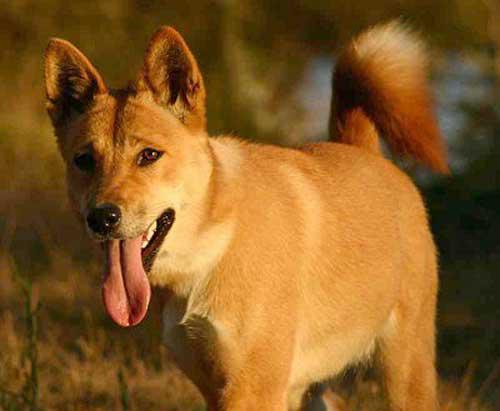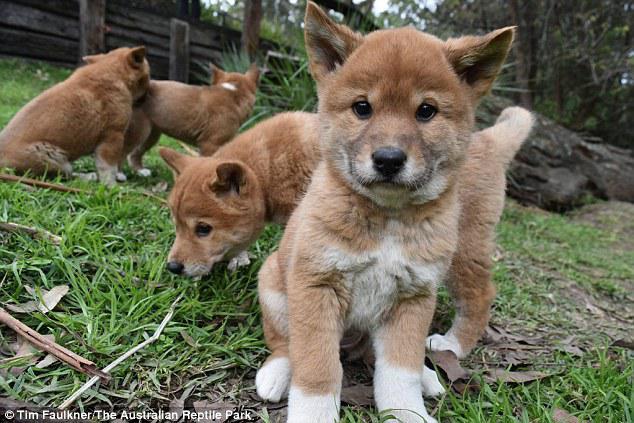The first image is the image on the left, the second image is the image on the right. For the images displayed, is the sentence "The right image contains at least two dingoes." factually correct? Answer yes or no. Yes. The first image is the image on the left, the second image is the image on the right. Evaluate the accuracy of this statement regarding the images: "There are at most 3 dingos in the image pair". Is it true? Answer yes or no. No. 